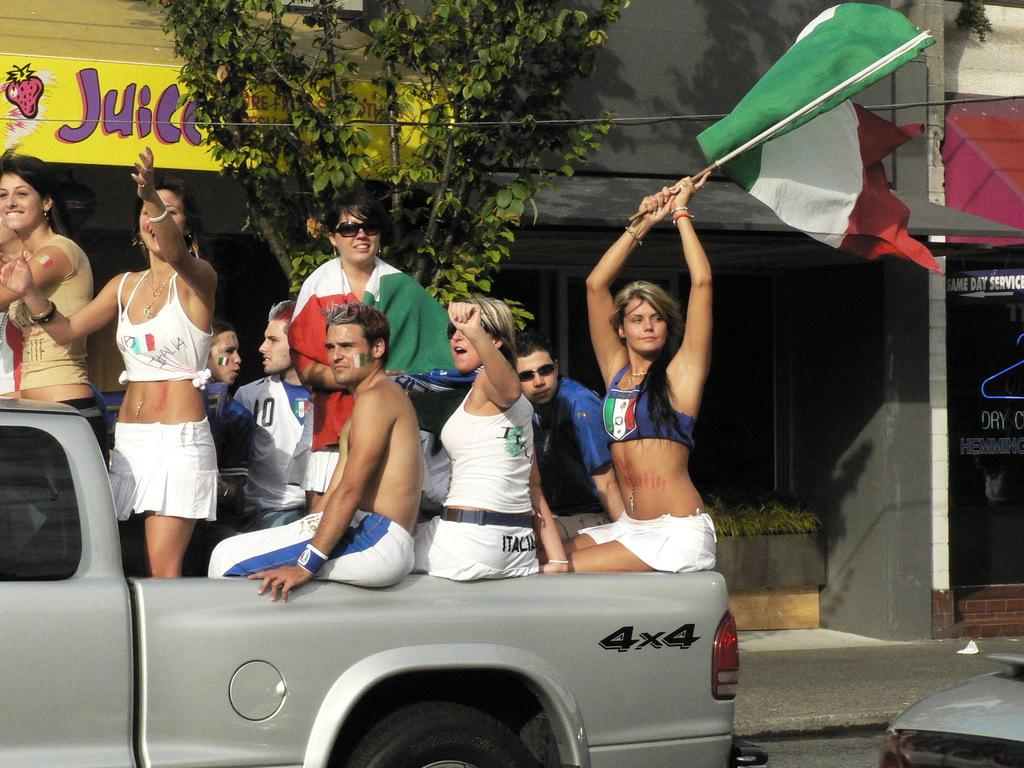How many people are in the image? There is a group of people in the image. What are the people doing in the image? The people are on a vehicle. What can be seen in the image besides the people and the vehicle? There is a flag, a tree, and buildings in the image. How does the rice feel when touched in the image? There is no rice present in the image, so it is not possible to answer that question. 